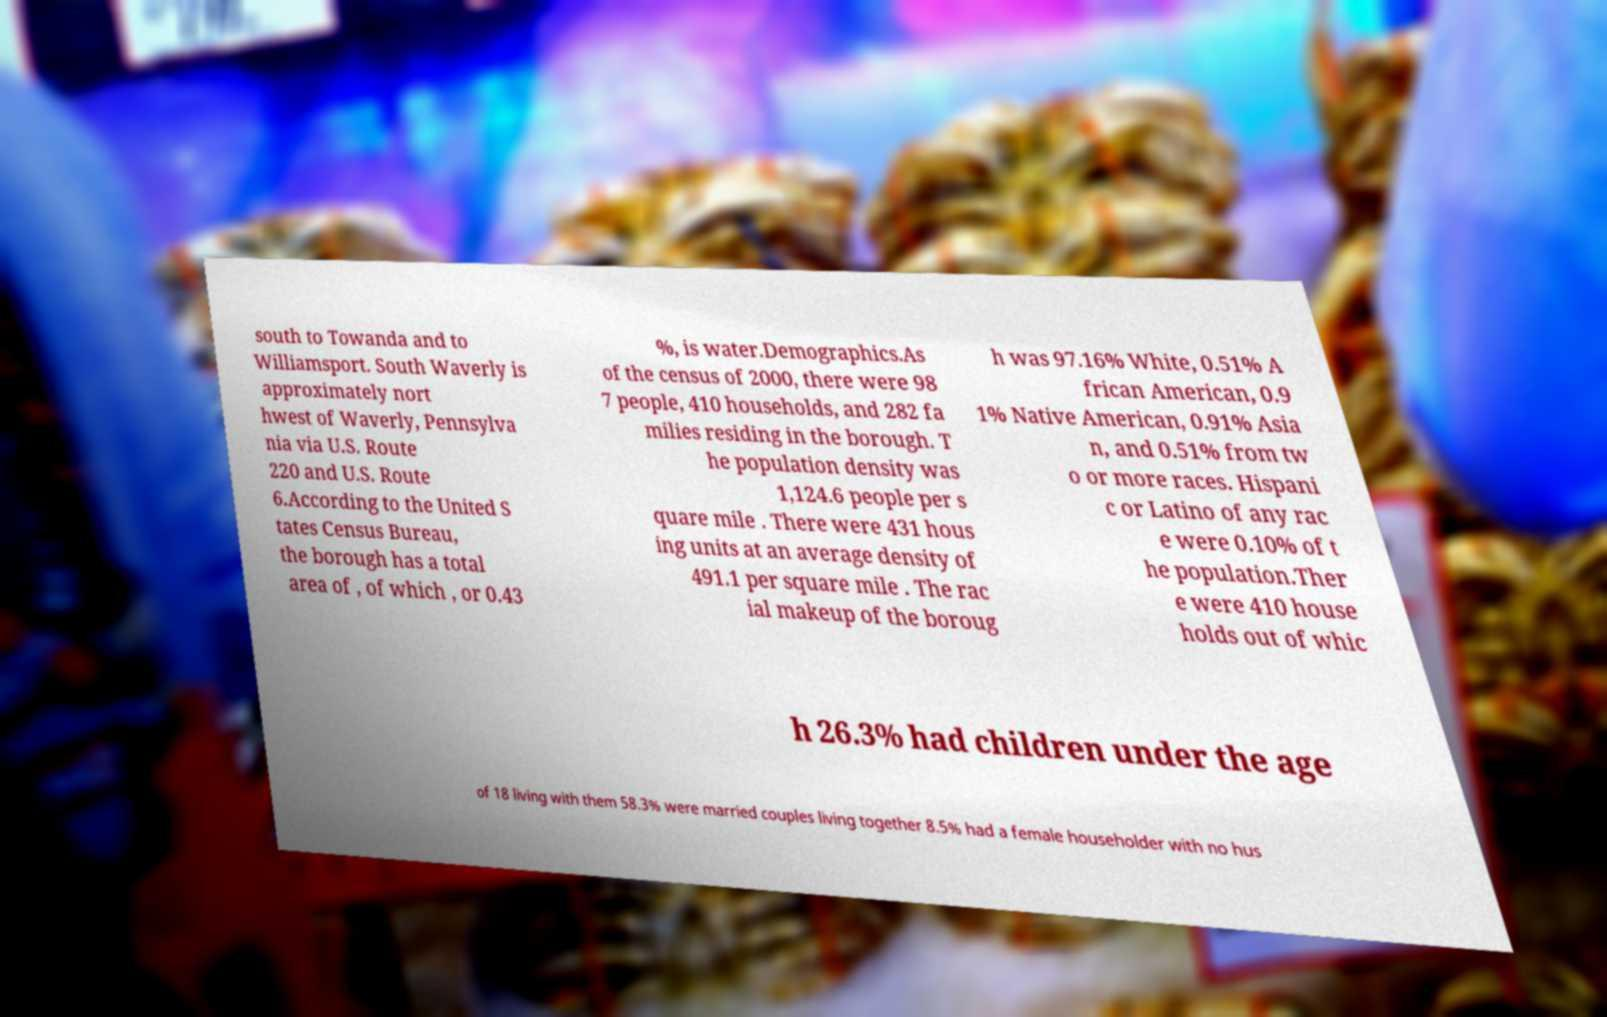What messages or text are displayed in this image? I need them in a readable, typed format. south to Towanda and to Williamsport. South Waverly is approximately nort hwest of Waverly, Pennsylva nia via U.S. Route 220 and U.S. Route 6.According to the United S tates Census Bureau, the borough has a total area of , of which , or 0.43 %, is water.Demographics.As of the census of 2000, there were 98 7 people, 410 households, and 282 fa milies residing in the borough. T he population density was 1,124.6 people per s quare mile . There were 431 hous ing units at an average density of 491.1 per square mile . The rac ial makeup of the boroug h was 97.16% White, 0.51% A frican American, 0.9 1% Native American, 0.91% Asia n, and 0.51% from tw o or more races. Hispani c or Latino of any rac e were 0.10% of t he population.Ther e were 410 house holds out of whic h 26.3% had children under the age of 18 living with them 58.3% were married couples living together 8.5% had a female householder with no hus 